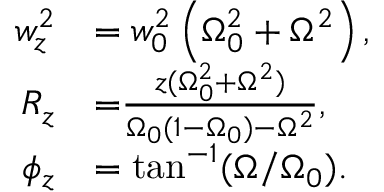Convert formula to latex. <formula><loc_0><loc_0><loc_500><loc_500>\begin{array} { r l } { w _ { z } ^ { 2 } } & { = w _ { 0 } ^ { 2 } \left ( \Omega _ { 0 } ^ { 2 } + \Omega ^ { 2 } \right ) , } \\ { { R _ { z } } } & { { = } \frac { z ( \Omega _ { 0 } ^ { 2 } + \Omega ^ { 2 } ) } { \Omega _ { 0 } ( 1 - \Omega _ { 0 } ) - \Omega ^ { 2 } } , } \\ { \phi _ { z } } & { = \tan ^ { - 1 } ( \Omega / \Omega _ { 0 } ) . } \end{array}</formula> 